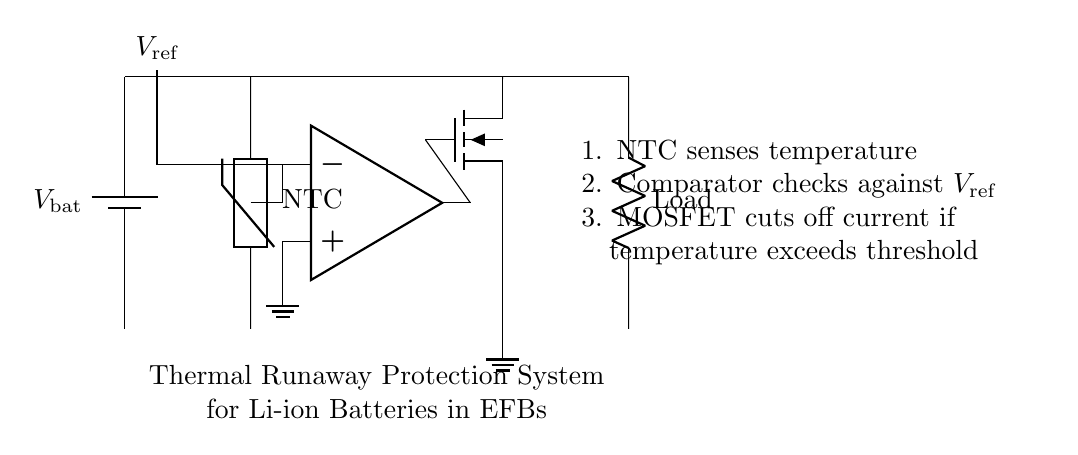What type of temperature sensor is used? The circuit diagram indicates an NTC thermistor. NTC stands for Negative Temperature Coefficient, implying its resistance decreases as temperature increases.
Answer: NTC thermistor What does the comparator compare? The comparator in the circuit compares the voltage from the NTC thermistor against a reference voltage. This comparison helps determine if the temperature exceeds a certain threshold.
Answer: Voltage from thermistor and reference voltage What happens when the temperature exceeds the threshold? The MOSFET will cut off the current flow to the load. This action prevents further heating of the lithium-ion battery, mitigating the risk of thermal runaway.
Answer: Current cutoff What is the purpose of the MOSFET in this circuit? The MOSFET acts as a switch that controls the current flow based on the comparator's output. When the comparator signals that the temperature is too high, the MOSFET turns off to protect the battery.
Answer: Switch to cut off current What role does the reference voltage play in the circuit? The reference voltage sets the threshold level against which the thermistor's voltage is compared. If the thermistor voltage falls below this level, it indicates that the temperature is too high.
Answer: Threshold level How does the NTC thermistor function in this circuit? The NTC thermistor senses the battery's temperature, generating a voltage that indicates whether the temperature is acceptable or exceeds the safe limits, thereby triggering the protective mechanism.
Answer: Senses temperature 